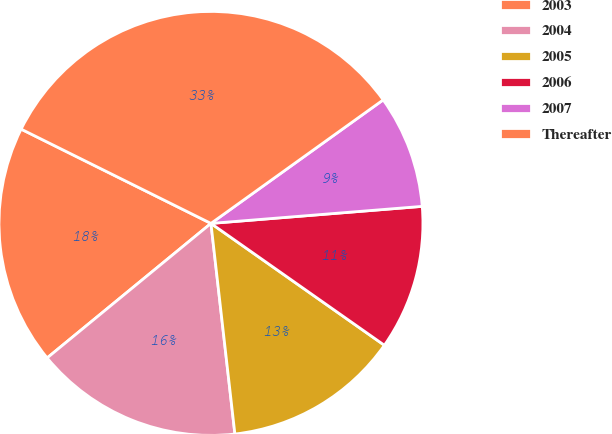<chart> <loc_0><loc_0><loc_500><loc_500><pie_chart><fcel>2003<fcel>2004<fcel>2005<fcel>2006<fcel>2007<fcel>Thereafter<nl><fcel>18.28%<fcel>15.86%<fcel>13.45%<fcel>11.03%<fcel>8.62%<fcel>32.76%<nl></chart> 